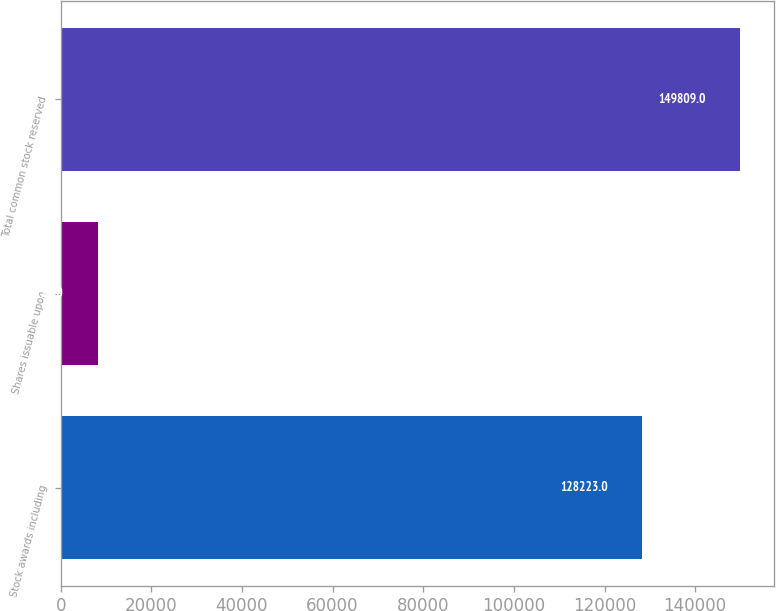<chart> <loc_0><loc_0><loc_500><loc_500><bar_chart><fcel>Stock awards including<fcel>Shares issuable upon<fcel>Total common stock reserved<nl><fcel>128223<fcel>8129<fcel>149809<nl></chart> 